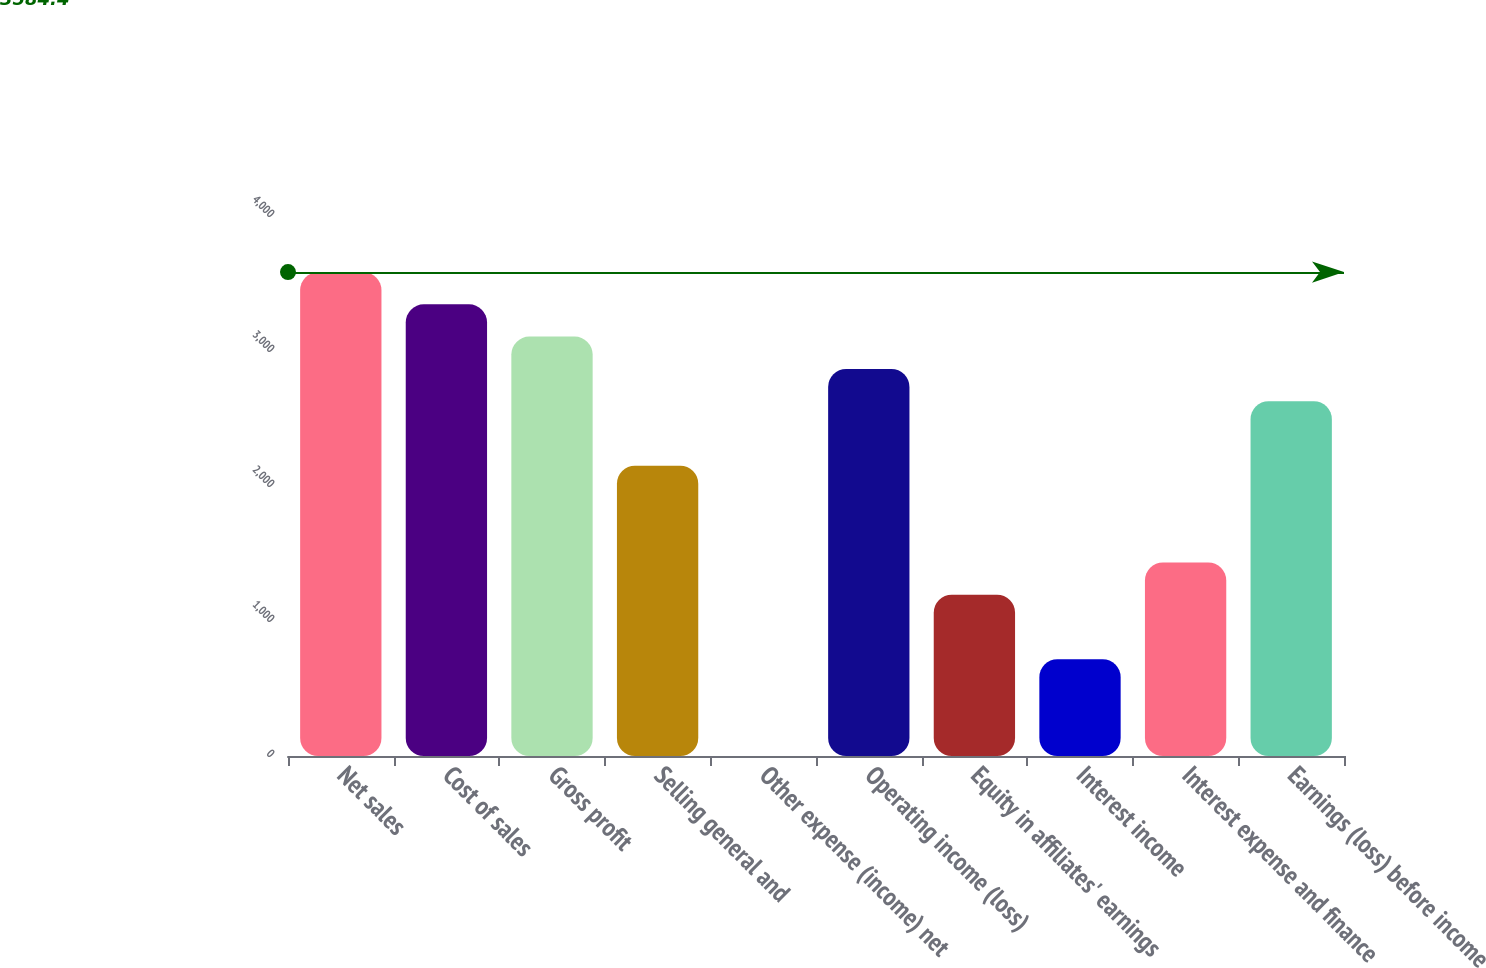Convert chart. <chart><loc_0><loc_0><loc_500><loc_500><bar_chart><fcel>Net sales<fcel>Cost of sales<fcel>Gross profit<fcel>Selling general and<fcel>Other expense (income) net<fcel>Operating income (loss)<fcel>Equity in affiliates' earnings<fcel>Interest income<fcel>Interest expense and finance<fcel>Earnings (loss) before income<nl><fcel>3584.4<fcel>3345.46<fcel>3106.52<fcel>2150.76<fcel>0.3<fcel>2867.58<fcel>1195<fcel>717.12<fcel>1433.94<fcel>2628.64<nl></chart> 